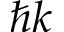<formula> <loc_0><loc_0><loc_500><loc_500>\hbar { k }</formula> 